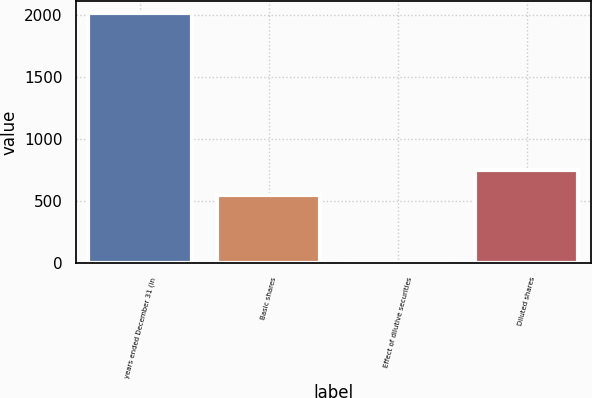Convert chart to OTSL. <chart><loc_0><loc_0><loc_500><loc_500><bar_chart><fcel>years ended December 31 (in<fcel>Basic shares<fcel>Effect of dilutive securities<fcel>Diluted shares<nl><fcel>2012<fcel>551<fcel>5<fcel>751.7<nl></chart> 